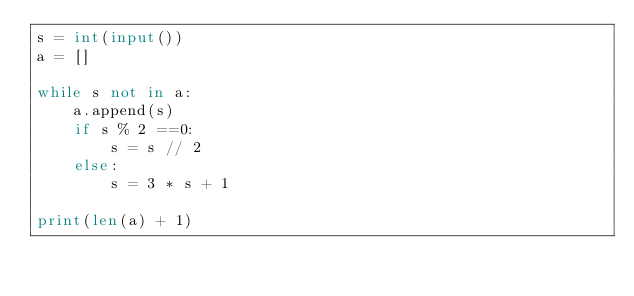Convert code to text. <code><loc_0><loc_0><loc_500><loc_500><_Python_>s = int(input())
a = []

while s not in a:
    a.append(s)
    if s % 2 ==0:
        s = s // 2
    else:
        s = 3 * s + 1

print(len(a) + 1)</code> 